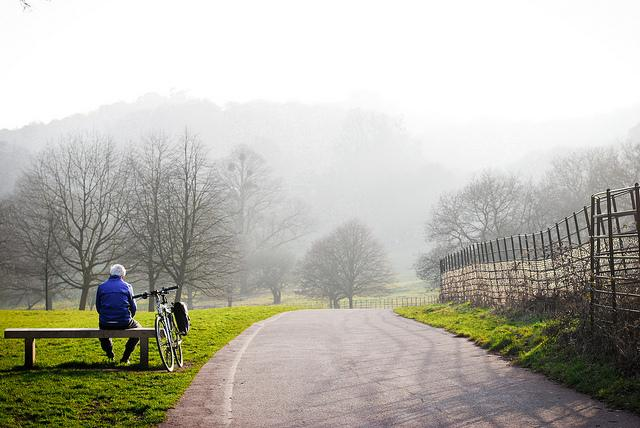Why is the sky so hazy? fog 